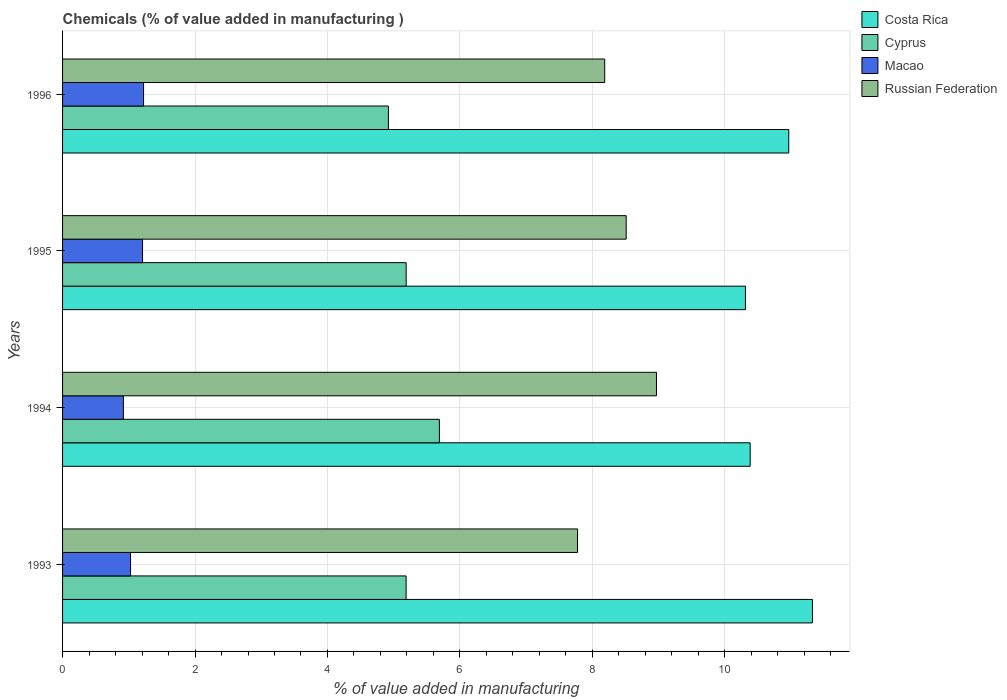How many different coloured bars are there?
Provide a succinct answer. 4. Are the number of bars per tick equal to the number of legend labels?
Give a very brief answer. Yes. How many bars are there on the 1st tick from the bottom?
Give a very brief answer. 4. What is the label of the 3rd group of bars from the top?
Your answer should be compact. 1994. What is the value added in manufacturing chemicals in Cyprus in 1996?
Your answer should be compact. 4.92. Across all years, what is the maximum value added in manufacturing chemicals in Cyprus?
Provide a succinct answer. 5.69. Across all years, what is the minimum value added in manufacturing chemicals in Russian Federation?
Keep it short and to the point. 7.78. What is the total value added in manufacturing chemicals in Russian Federation in the graph?
Provide a succinct answer. 33.44. What is the difference between the value added in manufacturing chemicals in Macao in 1994 and that in 1996?
Your answer should be very brief. -0.3. What is the difference between the value added in manufacturing chemicals in Macao in 1994 and the value added in manufacturing chemicals in Costa Rica in 1995?
Offer a very short reply. -9.39. What is the average value added in manufacturing chemicals in Macao per year?
Make the answer very short. 1.09. In the year 1994, what is the difference between the value added in manufacturing chemicals in Costa Rica and value added in manufacturing chemicals in Cyprus?
Offer a terse response. 4.69. In how many years, is the value added in manufacturing chemicals in Russian Federation greater than 6 %?
Make the answer very short. 4. What is the ratio of the value added in manufacturing chemicals in Costa Rica in 1993 to that in 1996?
Offer a very short reply. 1.03. Is the value added in manufacturing chemicals in Macao in 1993 less than that in 1996?
Your answer should be very brief. Yes. Is the difference between the value added in manufacturing chemicals in Costa Rica in 1993 and 1995 greater than the difference between the value added in manufacturing chemicals in Cyprus in 1993 and 1995?
Offer a very short reply. Yes. What is the difference between the highest and the second highest value added in manufacturing chemicals in Costa Rica?
Make the answer very short. 0.36. What is the difference between the highest and the lowest value added in manufacturing chemicals in Macao?
Your answer should be compact. 0.3. Is the sum of the value added in manufacturing chemicals in Macao in 1994 and 1996 greater than the maximum value added in manufacturing chemicals in Costa Rica across all years?
Provide a short and direct response. No. Is it the case that in every year, the sum of the value added in manufacturing chemicals in Macao and value added in manufacturing chemicals in Costa Rica is greater than the sum of value added in manufacturing chemicals in Cyprus and value added in manufacturing chemicals in Russian Federation?
Offer a terse response. Yes. What does the 2nd bar from the top in 1994 represents?
Keep it short and to the point. Macao. What does the 2nd bar from the bottom in 1995 represents?
Offer a very short reply. Cyprus. Are all the bars in the graph horizontal?
Your response must be concise. Yes. What is the difference between two consecutive major ticks on the X-axis?
Give a very brief answer. 2. Does the graph contain any zero values?
Offer a terse response. No. How many legend labels are there?
Your answer should be very brief. 4. How are the legend labels stacked?
Give a very brief answer. Vertical. What is the title of the graph?
Ensure brevity in your answer.  Chemicals (% of value added in manufacturing ). What is the label or title of the X-axis?
Your answer should be very brief. % of value added in manufacturing. What is the label or title of the Y-axis?
Offer a very short reply. Years. What is the % of value added in manufacturing of Costa Rica in 1993?
Offer a very short reply. 11.32. What is the % of value added in manufacturing of Cyprus in 1993?
Ensure brevity in your answer.  5.19. What is the % of value added in manufacturing in Macao in 1993?
Give a very brief answer. 1.03. What is the % of value added in manufacturing of Russian Federation in 1993?
Ensure brevity in your answer.  7.78. What is the % of value added in manufacturing of Costa Rica in 1994?
Provide a short and direct response. 10.38. What is the % of value added in manufacturing of Cyprus in 1994?
Your answer should be compact. 5.69. What is the % of value added in manufacturing in Macao in 1994?
Provide a short and direct response. 0.92. What is the % of value added in manufacturing of Russian Federation in 1994?
Provide a succinct answer. 8.97. What is the % of value added in manufacturing in Costa Rica in 1995?
Your response must be concise. 10.31. What is the % of value added in manufacturing of Cyprus in 1995?
Provide a short and direct response. 5.19. What is the % of value added in manufacturing of Macao in 1995?
Offer a very short reply. 1.21. What is the % of value added in manufacturing in Russian Federation in 1995?
Your answer should be very brief. 8.51. What is the % of value added in manufacturing in Costa Rica in 1996?
Provide a short and direct response. 10.97. What is the % of value added in manufacturing in Cyprus in 1996?
Your response must be concise. 4.92. What is the % of value added in manufacturing of Macao in 1996?
Your answer should be very brief. 1.22. What is the % of value added in manufacturing of Russian Federation in 1996?
Keep it short and to the point. 8.19. Across all years, what is the maximum % of value added in manufacturing in Costa Rica?
Your response must be concise. 11.32. Across all years, what is the maximum % of value added in manufacturing in Cyprus?
Your response must be concise. 5.69. Across all years, what is the maximum % of value added in manufacturing of Macao?
Keep it short and to the point. 1.22. Across all years, what is the maximum % of value added in manufacturing in Russian Federation?
Your response must be concise. 8.97. Across all years, what is the minimum % of value added in manufacturing in Costa Rica?
Offer a very short reply. 10.31. Across all years, what is the minimum % of value added in manufacturing in Cyprus?
Your answer should be very brief. 4.92. Across all years, what is the minimum % of value added in manufacturing in Macao?
Provide a succinct answer. 0.92. Across all years, what is the minimum % of value added in manufacturing in Russian Federation?
Provide a short and direct response. 7.78. What is the total % of value added in manufacturing of Costa Rica in the graph?
Your answer should be compact. 42.98. What is the total % of value added in manufacturing in Cyprus in the graph?
Your answer should be compact. 20.99. What is the total % of value added in manufacturing in Macao in the graph?
Provide a succinct answer. 4.38. What is the total % of value added in manufacturing in Russian Federation in the graph?
Your answer should be compact. 33.44. What is the difference between the % of value added in manufacturing of Costa Rica in 1993 and that in 1994?
Provide a succinct answer. 0.94. What is the difference between the % of value added in manufacturing in Cyprus in 1993 and that in 1994?
Keep it short and to the point. -0.5. What is the difference between the % of value added in manufacturing of Macao in 1993 and that in 1994?
Offer a terse response. 0.11. What is the difference between the % of value added in manufacturing of Russian Federation in 1993 and that in 1994?
Make the answer very short. -1.19. What is the difference between the % of value added in manufacturing in Costa Rica in 1993 and that in 1995?
Offer a terse response. 1.01. What is the difference between the % of value added in manufacturing of Cyprus in 1993 and that in 1995?
Your response must be concise. -0. What is the difference between the % of value added in manufacturing of Macao in 1993 and that in 1995?
Ensure brevity in your answer.  -0.18. What is the difference between the % of value added in manufacturing in Russian Federation in 1993 and that in 1995?
Your answer should be compact. -0.73. What is the difference between the % of value added in manufacturing in Costa Rica in 1993 and that in 1996?
Ensure brevity in your answer.  0.36. What is the difference between the % of value added in manufacturing in Cyprus in 1993 and that in 1996?
Ensure brevity in your answer.  0.27. What is the difference between the % of value added in manufacturing of Macao in 1993 and that in 1996?
Your answer should be very brief. -0.2. What is the difference between the % of value added in manufacturing of Russian Federation in 1993 and that in 1996?
Make the answer very short. -0.41. What is the difference between the % of value added in manufacturing in Costa Rica in 1994 and that in 1995?
Provide a succinct answer. 0.07. What is the difference between the % of value added in manufacturing of Cyprus in 1994 and that in 1995?
Your answer should be compact. 0.5. What is the difference between the % of value added in manufacturing in Macao in 1994 and that in 1995?
Your response must be concise. -0.29. What is the difference between the % of value added in manufacturing of Russian Federation in 1994 and that in 1995?
Offer a very short reply. 0.46. What is the difference between the % of value added in manufacturing in Costa Rica in 1994 and that in 1996?
Offer a terse response. -0.58. What is the difference between the % of value added in manufacturing of Cyprus in 1994 and that in 1996?
Offer a terse response. 0.77. What is the difference between the % of value added in manufacturing in Macao in 1994 and that in 1996?
Offer a very short reply. -0.3. What is the difference between the % of value added in manufacturing in Russian Federation in 1994 and that in 1996?
Your answer should be very brief. 0.78. What is the difference between the % of value added in manufacturing in Costa Rica in 1995 and that in 1996?
Your answer should be very brief. -0.65. What is the difference between the % of value added in manufacturing of Cyprus in 1995 and that in 1996?
Your answer should be very brief. 0.27. What is the difference between the % of value added in manufacturing of Macao in 1995 and that in 1996?
Your answer should be compact. -0.02. What is the difference between the % of value added in manufacturing in Russian Federation in 1995 and that in 1996?
Your answer should be compact. 0.32. What is the difference between the % of value added in manufacturing in Costa Rica in 1993 and the % of value added in manufacturing in Cyprus in 1994?
Offer a terse response. 5.63. What is the difference between the % of value added in manufacturing of Costa Rica in 1993 and the % of value added in manufacturing of Macao in 1994?
Offer a terse response. 10.4. What is the difference between the % of value added in manufacturing in Costa Rica in 1993 and the % of value added in manufacturing in Russian Federation in 1994?
Offer a terse response. 2.35. What is the difference between the % of value added in manufacturing of Cyprus in 1993 and the % of value added in manufacturing of Macao in 1994?
Your response must be concise. 4.27. What is the difference between the % of value added in manufacturing in Cyprus in 1993 and the % of value added in manufacturing in Russian Federation in 1994?
Provide a succinct answer. -3.78. What is the difference between the % of value added in manufacturing of Macao in 1993 and the % of value added in manufacturing of Russian Federation in 1994?
Your response must be concise. -7.94. What is the difference between the % of value added in manufacturing in Costa Rica in 1993 and the % of value added in manufacturing in Cyprus in 1995?
Your answer should be compact. 6.13. What is the difference between the % of value added in manufacturing in Costa Rica in 1993 and the % of value added in manufacturing in Macao in 1995?
Offer a terse response. 10.12. What is the difference between the % of value added in manufacturing in Costa Rica in 1993 and the % of value added in manufacturing in Russian Federation in 1995?
Provide a succinct answer. 2.81. What is the difference between the % of value added in manufacturing in Cyprus in 1993 and the % of value added in manufacturing in Macao in 1995?
Make the answer very short. 3.98. What is the difference between the % of value added in manufacturing of Cyprus in 1993 and the % of value added in manufacturing of Russian Federation in 1995?
Offer a very short reply. -3.32. What is the difference between the % of value added in manufacturing in Macao in 1993 and the % of value added in manufacturing in Russian Federation in 1995?
Provide a succinct answer. -7.48. What is the difference between the % of value added in manufacturing of Costa Rica in 1993 and the % of value added in manufacturing of Cyprus in 1996?
Make the answer very short. 6.4. What is the difference between the % of value added in manufacturing in Costa Rica in 1993 and the % of value added in manufacturing in Macao in 1996?
Ensure brevity in your answer.  10.1. What is the difference between the % of value added in manufacturing in Costa Rica in 1993 and the % of value added in manufacturing in Russian Federation in 1996?
Give a very brief answer. 3.14. What is the difference between the % of value added in manufacturing of Cyprus in 1993 and the % of value added in manufacturing of Macao in 1996?
Offer a terse response. 3.96. What is the difference between the % of value added in manufacturing of Cyprus in 1993 and the % of value added in manufacturing of Russian Federation in 1996?
Keep it short and to the point. -3. What is the difference between the % of value added in manufacturing of Macao in 1993 and the % of value added in manufacturing of Russian Federation in 1996?
Offer a very short reply. -7.16. What is the difference between the % of value added in manufacturing of Costa Rica in 1994 and the % of value added in manufacturing of Cyprus in 1995?
Your response must be concise. 5.19. What is the difference between the % of value added in manufacturing in Costa Rica in 1994 and the % of value added in manufacturing in Macao in 1995?
Make the answer very short. 9.18. What is the difference between the % of value added in manufacturing of Costa Rica in 1994 and the % of value added in manufacturing of Russian Federation in 1995?
Provide a succinct answer. 1.87. What is the difference between the % of value added in manufacturing in Cyprus in 1994 and the % of value added in manufacturing in Macao in 1995?
Give a very brief answer. 4.48. What is the difference between the % of value added in manufacturing of Cyprus in 1994 and the % of value added in manufacturing of Russian Federation in 1995?
Provide a succinct answer. -2.82. What is the difference between the % of value added in manufacturing of Macao in 1994 and the % of value added in manufacturing of Russian Federation in 1995?
Offer a very short reply. -7.59. What is the difference between the % of value added in manufacturing in Costa Rica in 1994 and the % of value added in manufacturing in Cyprus in 1996?
Provide a short and direct response. 5.46. What is the difference between the % of value added in manufacturing in Costa Rica in 1994 and the % of value added in manufacturing in Macao in 1996?
Your answer should be compact. 9.16. What is the difference between the % of value added in manufacturing of Costa Rica in 1994 and the % of value added in manufacturing of Russian Federation in 1996?
Your answer should be compact. 2.2. What is the difference between the % of value added in manufacturing of Cyprus in 1994 and the % of value added in manufacturing of Macao in 1996?
Ensure brevity in your answer.  4.47. What is the difference between the % of value added in manufacturing in Cyprus in 1994 and the % of value added in manufacturing in Russian Federation in 1996?
Provide a succinct answer. -2.5. What is the difference between the % of value added in manufacturing in Macao in 1994 and the % of value added in manufacturing in Russian Federation in 1996?
Ensure brevity in your answer.  -7.27. What is the difference between the % of value added in manufacturing in Costa Rica in 1995 and the % of value added in manufacturing in Cyprus in 1996?
Offer a very short reply. 5.39. What is the difference between the % of value added in manufacturing in Costa Rica in 1995 and the % of value added in manufacturing in Macao in 1996?
Offer a very short reply. 9.09. What is the difference between the % of value added in manufacturing of Costa Rica in 1995 and the % of value added in manufacturing of Russian Federation in 1996?
Make the answer very short. 2.13. What is the difference between the % of value added in manufacturing of Cyprus in 1995 and the % of value added in manufacturing of Macao in 1996?
Provide a short and direct response. 3.97. What is the difference between the % of value added in manufacturing of Cyprus in 1995 and the % of value added in manufacturing of Russian Federation in 1996?
Provide a succinct answer. -3. What is the difference between the % of value added in manufacturing of Macao in 1995 and the % of value added in manufacturing of Russian Federation in 1996?
Your response must be concise. -6.98. What is the average % of value added in manufacturing of Costa Rica per year?
Your answer should be very brief. 10.75. What is the average % of value added in manufacturing in Cyprus per year?
Provide a succinct answer. 5.25. What is the average % of value added in manufacturing in Macao per year?
Make the answer very short. 1.09. What is the average % of value added in manufacturing of Russian Federation per year?
Your answer should be very brief. 8.36. In the year 1993, what is the difference between the % of value added in manufacturing of Costa Rica and % of value added in manufacturing of Cyprus?
Provide a short and direct response. 6.14. In the year 1993, what is the difference between the % of value added in manufacturing in Costa Rica and % of value added in manufacturing in Macao?
Provide a succinct answer. 10.3. In the year 1993, what is the difference between the % of value added in manufacturing in Costa Rica and % of value added in manufacturing in Russian Federation?
Make the answer very short. 3.55. In the year 1993, what is the difference between the % of value added in manufacturing of Cyprus and % of value added in manufacturing of Macao?
Ensure brevity in your answer.  4.16. In the year 1993, what is the difference between the % of value added in manufacturing in Cyprus and % of value added in manufacturing in Russian Federation?
Your response must be concise. -2.59. In the year 1993, what is the difference between the % of value added in manufacturing of Macao and % of value added in manufacturing of Russian Federation?
Offer a terse response. -6.75. In the year 1994, what is the difference between the % of value added in manufacturing in Costa Rica and % of value added in manufacturing in Cyprus?
Your response must be concise. 4.69. In the year 1994, what is the difference between the % of value added in manufacturing in Costa Rica and % of value added in manufacturing in Macao?
Offer a terse response. 9.46. In the year 1994, what is the difference between the % of value added in manufacturing in Costa Rica and % of value added in manufacturing in Russian Federation?
Offer a very short reply. 1.41. In the year 1994, what is the difference between the % of value added in manufacturing of Cyprus and % of value added in manufacturing of Macao?
Offer a terse response. 4.77. In the year 1994, what is the difference between the % of value added in manufacturing of Cyprus and % of value added in manufacturing of Russian Federation?
Give a very brief answer. -3.28. In the year 1994, what is the difference between the % of value added in manufacturing in Macao and % of value added in manufacturing in Russian Federation?
Provide a succinct answer. -8.05. In the year 1995, what is the difference between the % of value added in manufacturing in Costa Rica and % of value added in manufacturing in Cyprus?
Offer a very short reply. 5.12. In the year 1995, what is the difference between the % of value added in manufacturing in Costa Rica and % of value added in manufacturing in Macao?
Provide a succinct answer. 9.1. In the year 1995, what is the difference between the % of value added in manufacturing of Costa Rica and % of value added in manufacturing of Russian Federation?
Provide a short and direct response. 1.8. In the year 1995, what is the difference between the % of value added in manufacturing of Cyprus and % of value added in manufacturing of Macao?
Provide a succinct answer. 3.98. In the year 1995, what is the difference between the % of value added in manufacturing of Cyprus and % of value added in manufacturing of Russian Federation?
Offer a terse response. -3.32. In the year 1995, what is the difference between the % of value added in manufacturing in Macao and % of value added in manufacturing in Russian Federation?
Provide a succinct answer. -7.3. In the year 1996, what is the difference between the % of value added in manufacturing of Costa Rica and % of value added in manufacturing of Cyprus?
Your answer should be very brief. 6.05. In the year 1996, what is the difference between the % of value added in manufacturing in Costa Rica and % of value added in manufacturing in Macao?
Provide a succinct answer. 9.74. In the year 1996, what is the difference between the % of value added in manufacturing in Costa Rica and % of value added in manufacturing in Russian Federation?
Ensure brevity in your answer.  2.78. In the year 1996, what is the difference between the % of value added in manufacturing in Cyprus and % of value added in manufacturing in Macao?
Provide a succinct answer. 3.7. In the year 1996, what is the difference between the % of value added in manufacturing of Cyprus and % of value added in manufacturing of Russian Federation?
Ensure brevity in your answer.  -3.27. In the year 1996, what is the difference between the % of value added in manufacturing in Macao and % of value added in manufacturing in Russian Federation?
Your response must be concise. -6.96. What is the ratio of the % of value added in manufacturing in Costa Rica in 1993 to that in 1994?
Your answer should be compact. 1.09. What is the ratio of the % of value added in manufacturing in Cyprus in 1993 to that in 1994?
Your answer should be very brief. 0.91. What is the ratio of the % of value added in manufacturing of Macao in 1993 to that in 1994?
Ensure brevity in your answer.  1.12. What is the ratio of the % of value added in manufacturing in Russian Federation in 1993 to that in 1994?
Offer a terse response. 0.87. What is the ratio of the % of value added in manufacturing of Costa Rica in 1993 to that in 1995?
Make the answer very short. 1.1. What is the ratio of the % of value added in manufacturing in Cyprus in 1993 to that in 1995?
Offer a terse response. 1. What is the ratio of the % of value added in manufacturing of Macao in 1993 to that in 1995?
Provide a succinct answer. 0.85. What is the ratio of the % of value added in manufacturing of Russian Federation in 1993 to that in 1995?
Your response must be concise. 0.91. What is the ratio of the % of value added in manufacturing of Costa Rica in 1993 to that in 1996?
Your answer should be compact. 1.03. What is the ratio of the % of value added in manufacturing in Cyprus in 1993 to that in 1996?
Your answer should be very brief. 1.05. What is the ratio of the % of value added in manufacturing of Macao in 1993 to that in 1996?
Your answer should be very brief. 0.84. What is the ratio of the % of value added in manufacturing in Russian Federation in 1993 to that in 1996?
Offer a terse response. 0.95. What is the ratio of the % of value added in manufacturing in Cyprus in 1994 to that in 1995?
Your answer should be very brief. 1.1. What is the ratio of the % of value added in manufacturing in Macao in 1994 to that in 1995?
Give a very brief answer. 0.76. What is the ratio of the % of value added in manufacturing in Russian Federation in 1994 to that in 1995?
Make the answer very short. 1.05. What is the ratio of the % of value added in manufacturing in Costa Rica in 1994 to that in 1996?
Your answer should be very brief. 0.95. What is the ratio of the % of value added in manufacturing in Cyprus in 1994 to that in 1996?
Give a very brief answer. 1.16. What is the ratio of the % of value added in manufacturing of Macao in 1994 to that in 1996?
Your answer should be compact. 0.75. What is the ratio of the % of value added in manufacturing of Russian Federation in 1994 to that in 1996?
Keep it short and to the point. 1.1. What is the ratio of the % of value added in manufacturing in Costa Rica in 1995 to that in 1996?
Provide a succinct answer. 0.94. What is the ratio of the % of value added in manufacturing of Cyprus in 1995 to that in 1996?
Keep it short and to the point. 1.05. What is the ratio of the % of value added in manufacturing in Macao in 1995 to that in 1996?
Ensure brevity in your answer.  0.99. What is the ratio of the % of value added in manufacturing of Russian Federation in 1995 to that in 1996?
Offer a terse response. 1.04. What is the difference between the highest and the second highest % of value added in manufacturing of Costa Rica?
Ensure brevity in your answer.  0.36. What is the difference between the highest and the second highest % of value added in manufacturing of Cyprus?
Your answer should be compact. 0.5. What is the difference between the highest and the second highest % of value added in manufacturing of Macao?
Offer a terse response. 0.02. What is the difference between the highest and the second highest % of value added in manufacturing in Russian Federation?
Ensure brevity in your answer.  0.46. What is the difference between the highest and the lowest % of value added in manufacturing of Costa Rica?
Give a very brief answer. 1.01. What is the difference between the highest and the lowest % of value added in manufacturing of Cyprus?
Make the answer very short. 0.77. What is the difference between the highest and the lowest % of value added in manufacturing of Macao?
Provide a short and direct response. 0.3. What is the difference between the highest and the lowest % of value added in manufacturing in Russian Federation?
Provide a succinct answer. 1.19. 